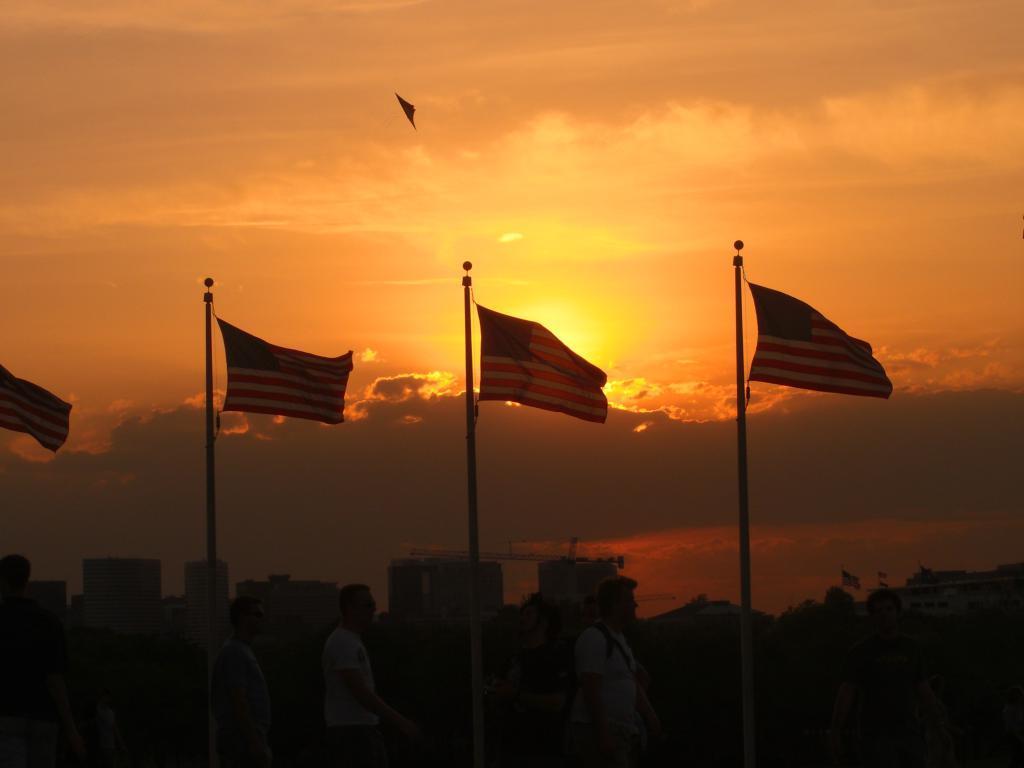Describe this image in one or two sentences. Here the image is dark but we can see three men standing on the ground and there are flags and poles here. In the background there are buildings,an object flying in the sky and clouds. 